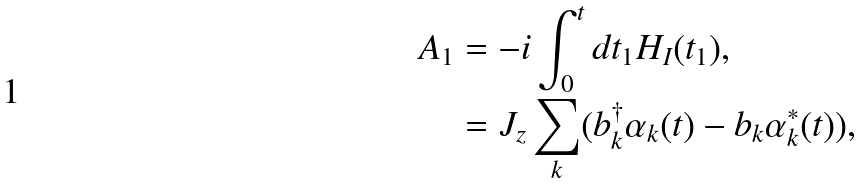<formula> <loc_0><loc_0><loc_500><loc_500>A _ { 1 } & = - i \int _ { 0 } ^ { t } d t _ { 1 } H _ { I } ( t _ { 1 } ) , \\ & = J _ { z } \sum _ { k } ( b _ { k } ^ { \dagger } \alpha _ { k } ( t ) - b _ { k } \alpha _ { k } ^ { * } ( t ) ) ,</formula> 